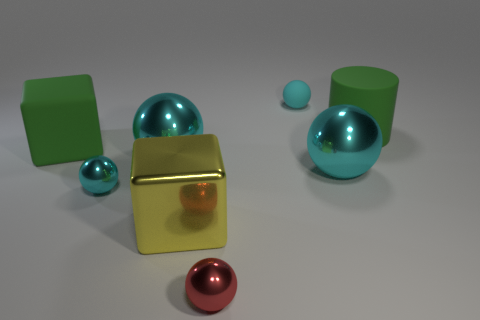Is the big rubber cylinder the same color as the large metal block?
Give a very brief answer. No. Is the big cyan sphere right of the red shiny sphere made of the same material as the big cyan ball on the left side of the tiny red sphere?
Your response must be concise. Yes. How many things are either large green cylinders or tiny balls in front of the green rubber cylinder?
Keep it short and to the point. 3. Is there anything else that has the same material as the big yellow cube?
Give a very brief answer. Yes. The big matte object that is the same color as the big rubber cylinder is what shape?
Provide a short and direct response. Cube. What is the material of the large yellow object?
Your answer should be compact. Metal. Do the cylinder and the red thing have the same material?
Ensure brevity in your answer.  No. What number of matte objects are small cyan spheres or big yellow blocks?
Offer a very short reply. 1. What is the shape of the green object that is to the right of the cyan rubber ball?
Provide a short and direct response. Cylinder. There is a red thing that is the same material as the big yellow cube; what is its size?
Keep it short and to the point. Small. 